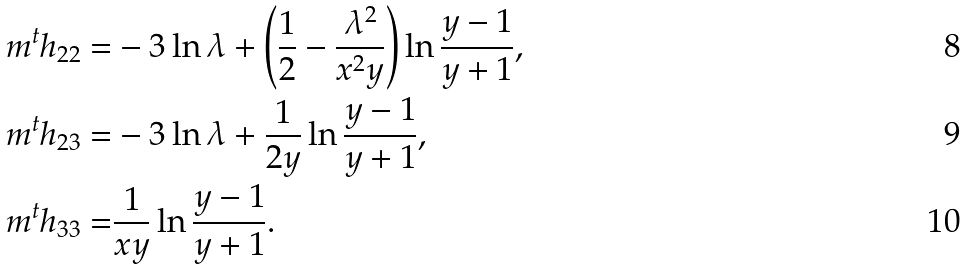<formula> <loc_0><loc_0><loc_500><loc_500>m ^ { t } h _ { 2 2 } = & - 3 \ln \lambda + \left ( \frac { 1 } { 2 } - \frac { \lambda ^ { 2 } } { x ^ { 2 } y } \right ) \ln \frac { y - 1 } { y + 1 } , \\ m ^ { t } h _ { 2 3 } = & - 3 \ln \lambda + \frac { 1 } { 2 y } \ln \frac { y - 1 } { y + 1 } , \\ m ^ { t } h _ { 3 3 } = & \frac { 1 } { x y } \ln \frac { y - 1 } { y + 1 } .</formula> 